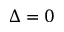Convert formula to latex. <formula><loc_0><loc_0><loc_500><loc_500>\Delta = 0</formula> 